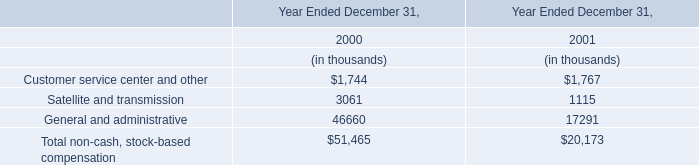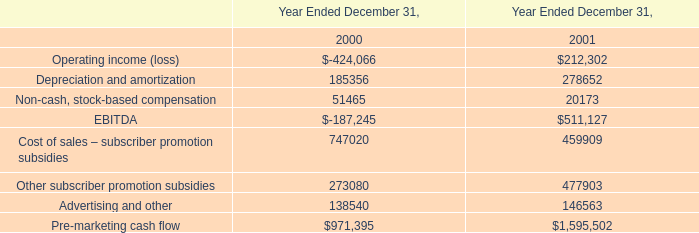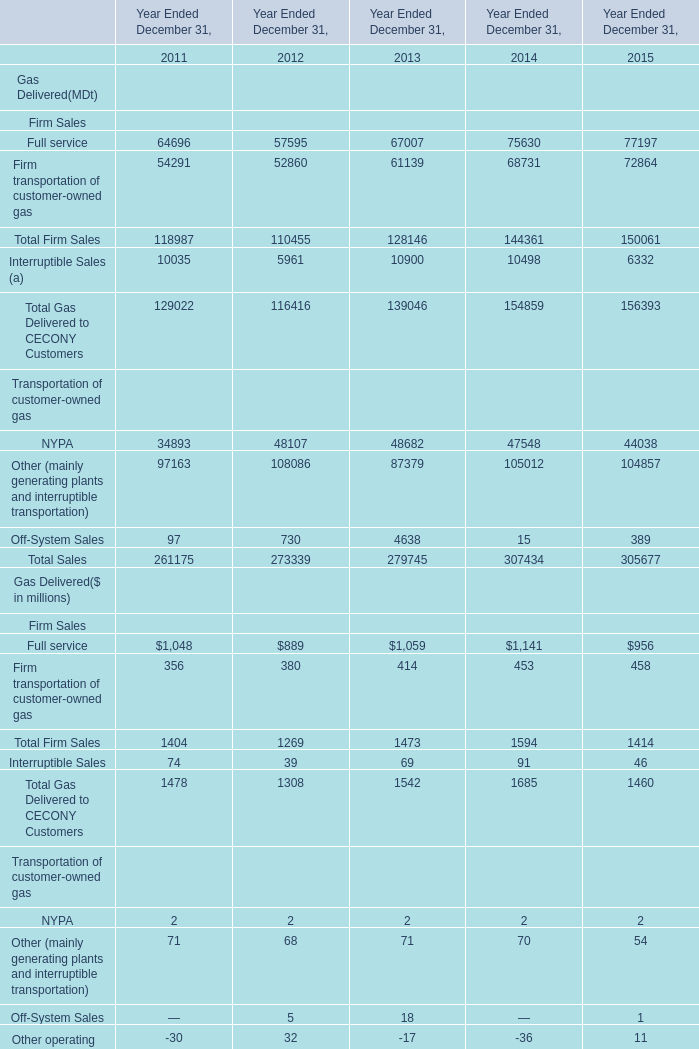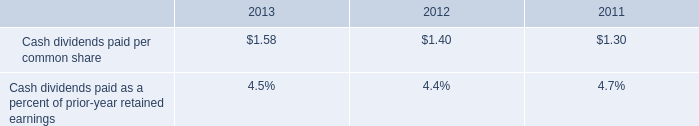Which year is Total Firm Sales greater than 150000 ? 
Answer: 2015. 